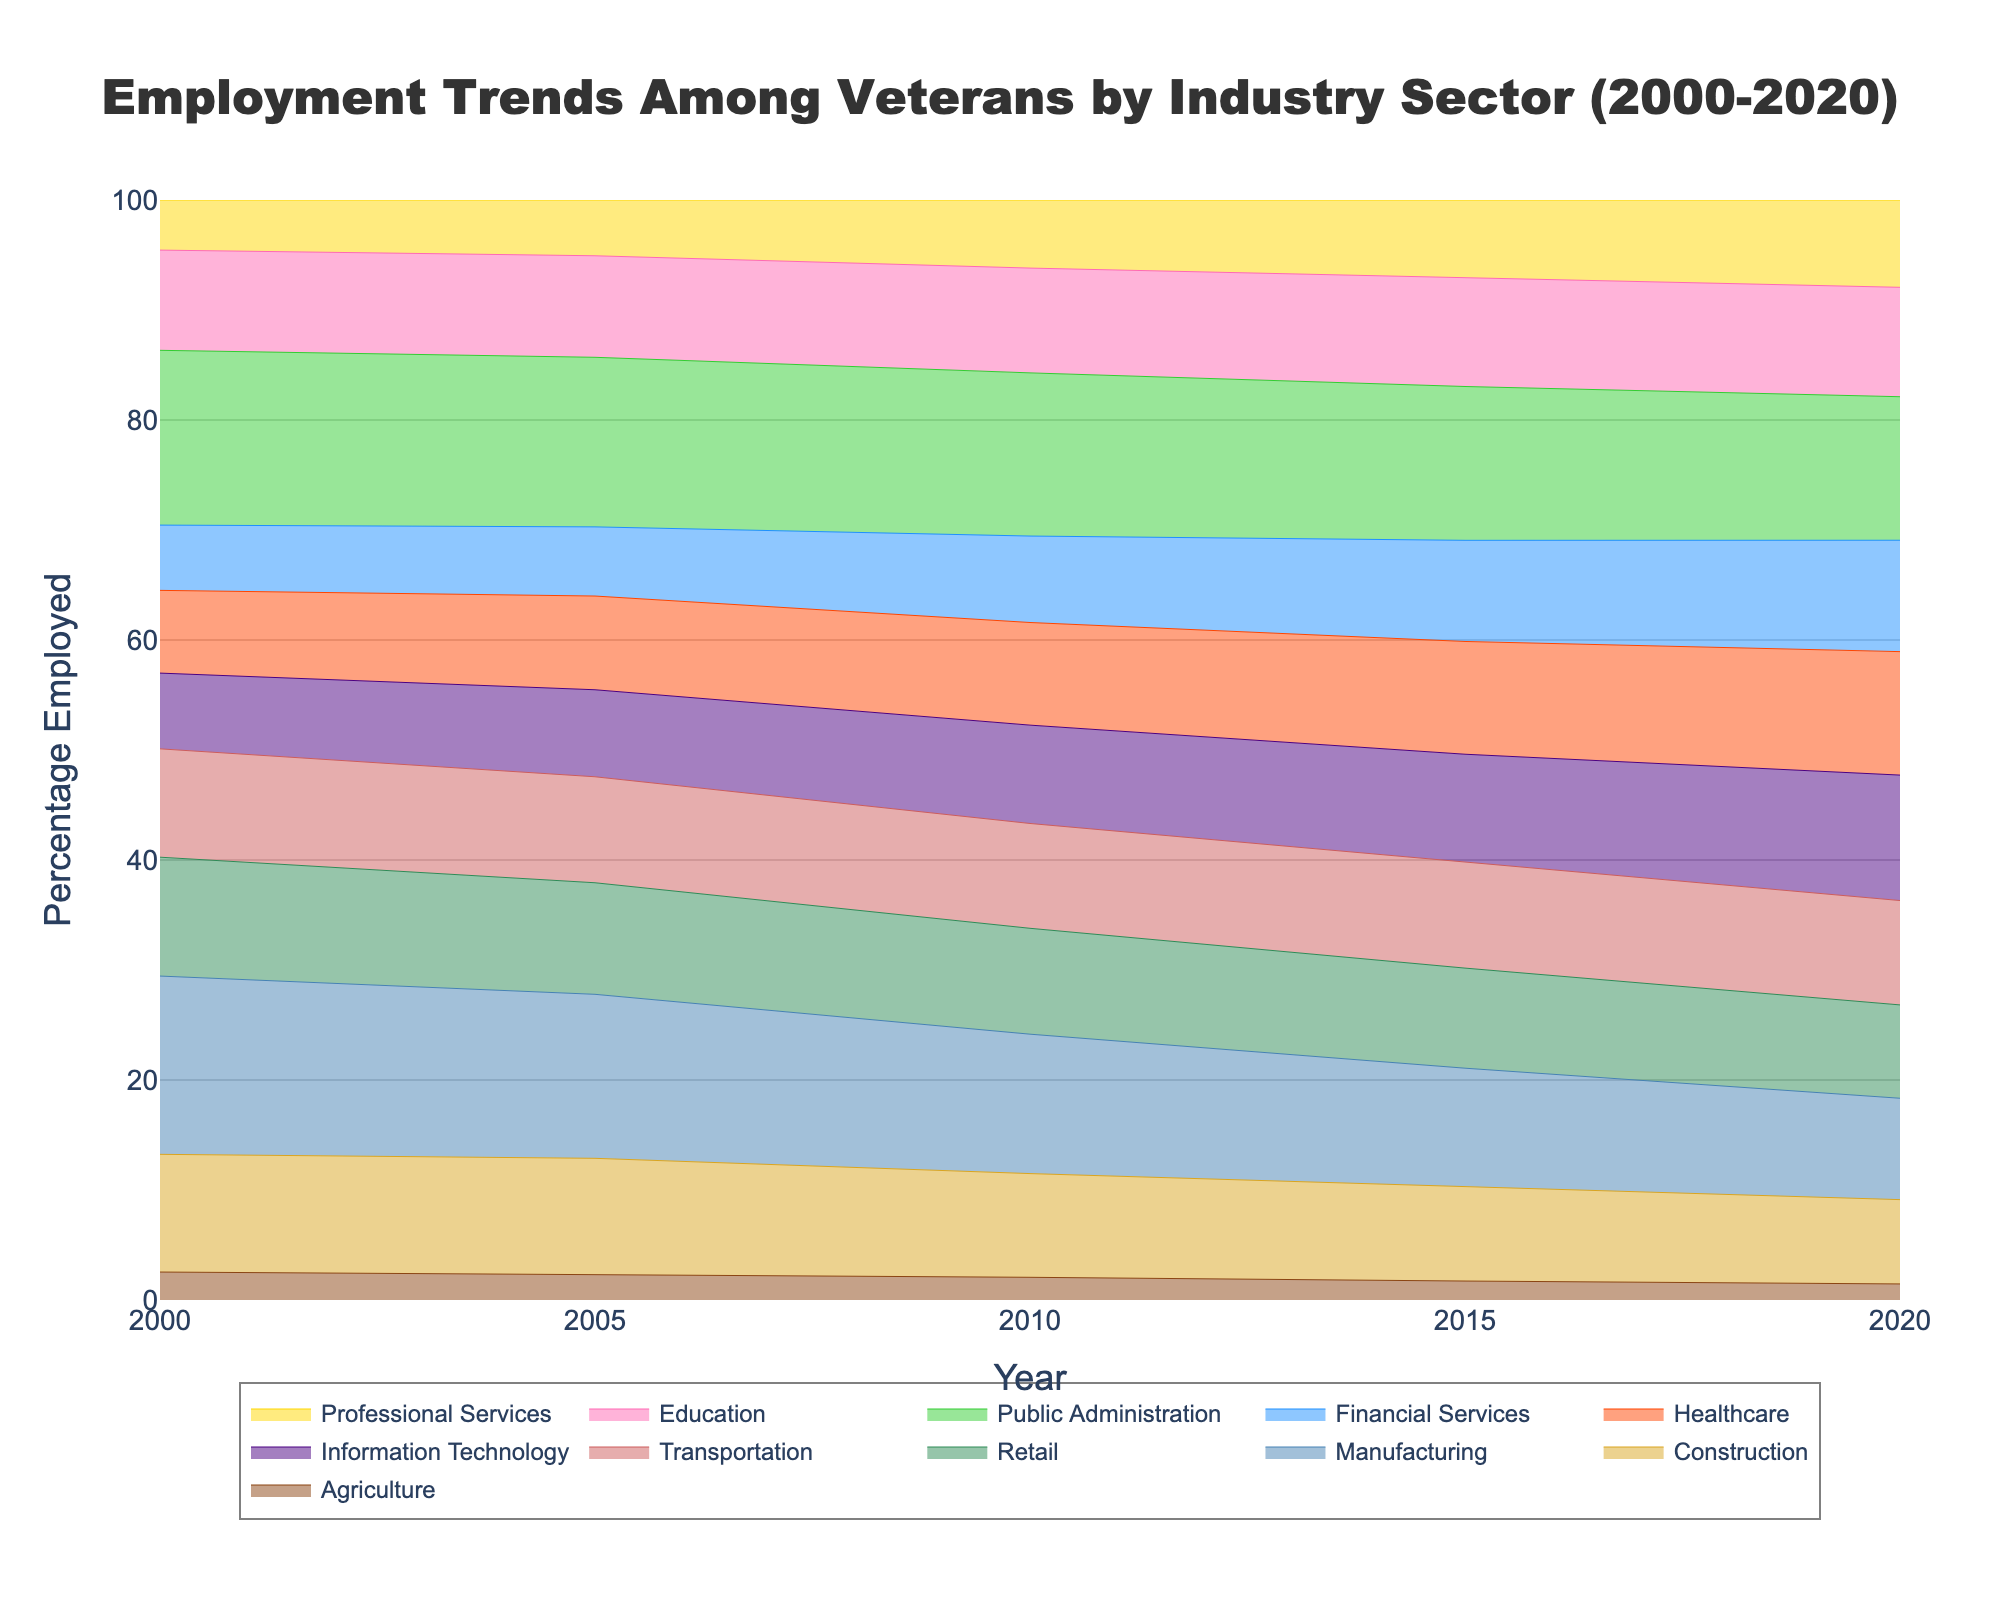What is the title of the figure? The title is typically located at the top center of the figure. In this case, it can be found at the top of the Stream graph.
Answer: Employment Trends Among Veterans by Industry Sector (2000-2020) Which sector shows a consistent increase in employment percentage from 2000 to 2020? To answer, look for the sector whose percentage employed trend line consistently moves upwards from 2000 to 2020. The IT and Healthcare sectors are the likely candidates here.
Answer: Information Technology and Healthcare What was the approximate percentage of veterans employed in the Agriculture sector in 2020? Find the Agriculture sector in the legend and follow its trend line to the year 2020. Check the y-axis for the corresponding value.
Answer: 1.6% Which sector had the highest percentage of veteran employment in 2000? Locate the year 2000 on the x-axis and identify the sector whose trend line has the highest value on the y-axis for that year.
Answer: Public Administration How did the employment percentage in the Manufacturing sector change from 2000 to 2020? Track the Manufacturing sector's trend line from the year 2000 to 2020 and note the starting and ending percentages on the y-axis.
Answer: Decreased from 15.3% to 10.1% Which sector had a higher employment percentage in 2010, Financial Services or Education? Compare the trend lines for Financial Services and Education at the year 2010 and see which one is higher on the y-axis.
Answer: Education By how much did the employment percentage in Professional Services increase between 2000 and 2020? Find the percentages for Professional Services in 2000 and 2020 and subtract the former from the latter.
Answer: 4.4% What trend can be observed in the Construction sector between 2005 and 2015? Look at the trend line for Construction between the years 2005 and 2015 to determine whether it moves upwards, downwards, or remains stable.
Answer: Downwards Which sector experienced a decrease in employment percentage from 2015 to 2020? Look at the trend lines between the years 2015 and 2020 and find the sectors where the line moves downward. For example, Manufacturing and Public Administration.
Answer: Manufacturing and Public Administration Which sectors had a percentage employment of approximately 10% in 2020? Locate the year 2020 on the x-axis and identify the sectors whose trend lines are around the 10% mark on the y-axis.
Answer: Education, Transportation, and Manufacturing 